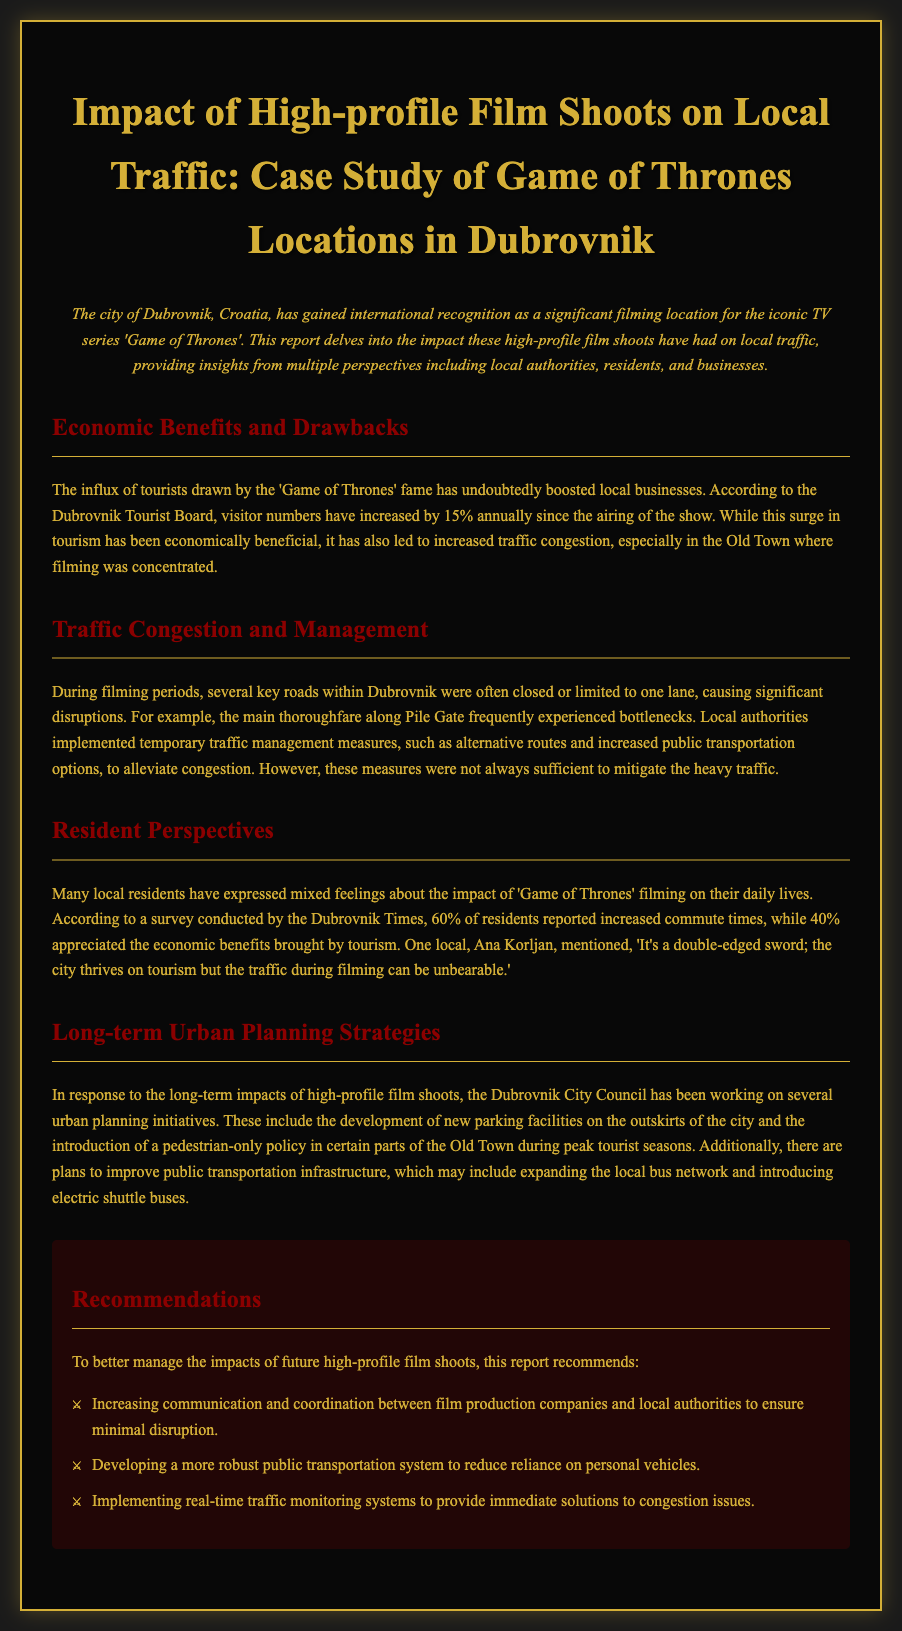What is the annual increase in visitor numbers since the airing of Game of Thrones? The report states that visitor numbers have increased by 15% annually since the airing of the show.
Answer: 15% What percentage of residents reported increased commute times? According to the survey, 60% of residents reported increased commute times.
Answer: 60% What is a key traffic congestion issue mentioned in the document? The main thoroughfare along Pile Gate frequently experienced bottlenecks during filming periods.
Answer: Bottlenecks What percentage of residents appreciated the economic benefits from tourism? According to the survey, 40% of residents appreciated the economic benefits brought by tourism.
Answer: 40% What is one initiative the Dubrovnik City Council is working on? The report mentions the development of new parking facilities on the outskirts of the city as one initiative.
Answer: New parking facilities What type of monitoring systems does the report recommend? The report recommends implementing real-time traffic monitoring systems for congestion issues.
Answer: Real-time traffic monitoring systems What is a notable economic impact of Game of Thrones filming on local businesses? The influx of tourists has boosted local businesses due to increased visitor numbers.
Answer: Boosted local businesses What is a suggested improvement to public transportation? The report suggests introducing electric shuttle buses as an improvement to public transportation.
Answer: Electric shuttle buses What feeling did resident Ana Korljan express about the filming's impact? Ana Korljan expressed that it's a double-edged sword regarding the benefits and traffic issues.
Answer: Double-edged sword 